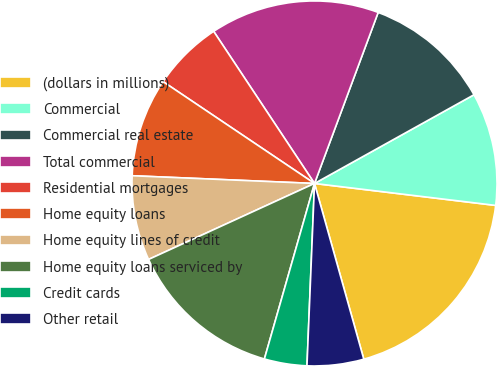<chart> <loc_0><loc_0><loc_500><loc_500><pie_chart><fcel>(dollars in millions)<fcel>Commercial<fcel>Commercial real estate<fcel>Total commercial<fcel>Residential mortgages<fcel>Home equity loans<fcel>Home equity lines of credit<fcel>Home equity loans serviced by<fcel>Credit cards<fcel>Other retail<nl><fcel>18.73%<fcel>10.0%<fcel>11.25%<fcel>14.99%<fcel>6.26%<fcel>8.75%<fcel>7.51%<fcel>13.74%<fcel>3.77%<fcel>5.01%<nl></chart> 